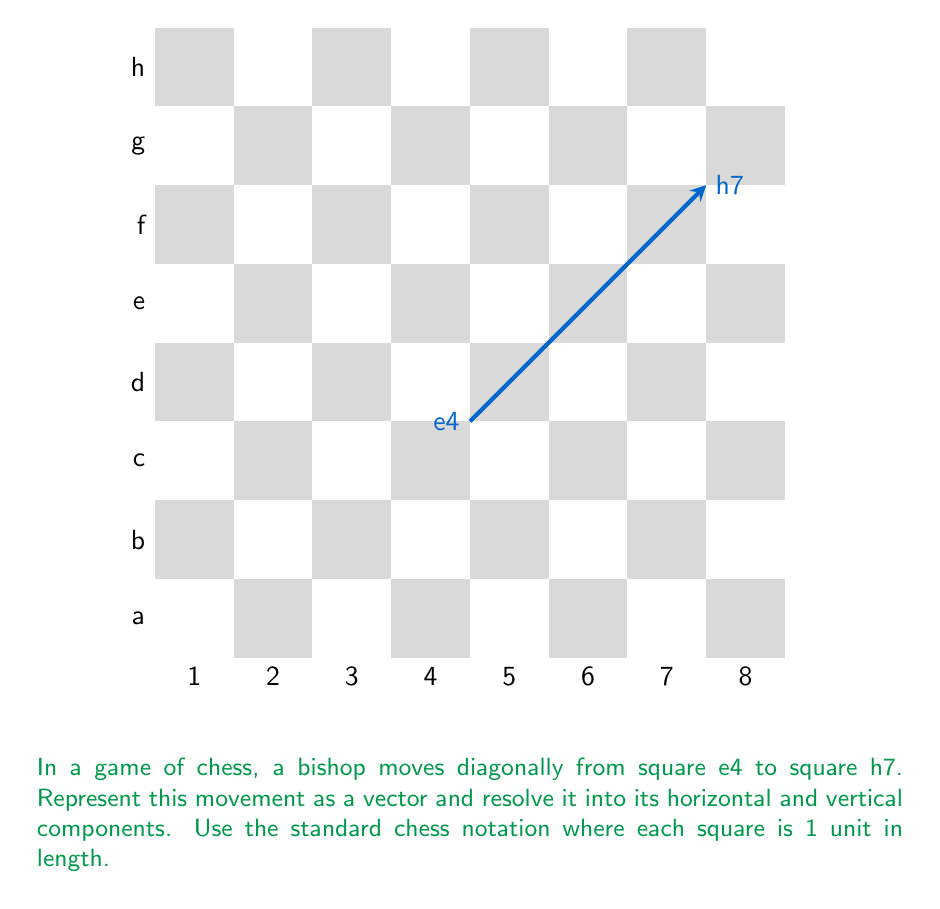Can you solve this math problem? Let's approach this step-by-step:

1) First, we need to determine the vector of the bishop's movement. 
   - The bishop moves from e4 to h7
   - In chess notation, e is the 5th column, and h is the 8th column
   - 4 is the 4th row, and 7 is the 7th row
   - So, the movement is 3 squares right and 3 squares up

2) We can represent this as a vector:
   $$\vec{v} = (3, 3)$$

3) This vector is already in component form, where:
   - The horizontal component is $v_x = 3$
   - The vertical component is $v_y = 3$

4) We can express this mathematically as:
   $$\vec{v} = 3\hat{i} + 3\hat{j}$$
   where $\hat{i}$ is the unit vector in the horizontal direction and $\hat{j}$ is the unit vector in the vertical direction.

5) The magnitude of this vector can be calculated using the Pythagorean theorem:
   $$|\vec{v}| = \sqrt{3^2 + 3^2} = \sqrt{18} = 3\sqrt{2}$$

6) We can also express the vector in polar form:
   - The angle $\theta = \tan^{-1}(\frac{3}{3}) = 45°$
   - So, $\vec{v} = 3\sqrt{2}(\cos 45°, \sin 45°)$

Therefore, the bishop's diagonal movement can be represented as a vector (3, 3), which resolves into a horizontal component of 3 units and a vertical component of 3 units.
Answer: $\vec{v} = 3\hat{i} + 3\hat{j}$ 